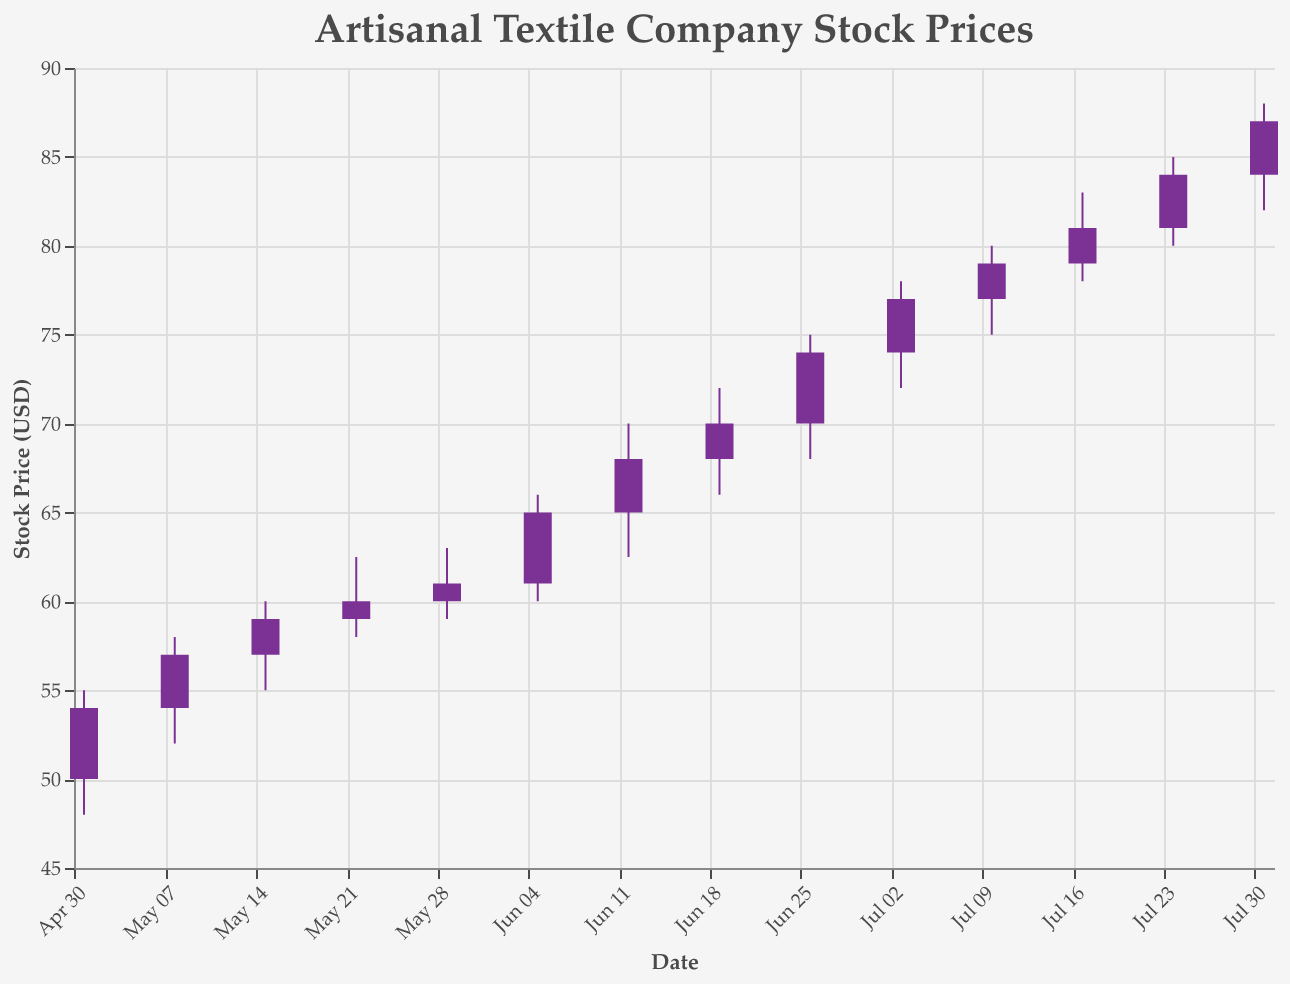How many candlesticks in the plot indicate a rise in stock price? To find the number of candlesticks that indicate a rise in the stock price, look for bars that are colored differently indicating an increase (open price is less than close price). Count these candlesticks from the plot.
Answer: 13 What is the closing price on July 31st, 2023? Locate the candlestick corresponding to July 31st, 2023 on the x-axis. Check the top of the thicker part of the candlestick for the closing price.
Answer: 87.00 Which week experienced the highest trading volume? Check the y-axis values related to the volume of shares traded each week. Identify the candlestick/use the associated line showing the volume. Look for the week with the highest volume.
Answer: July 31st, 2023 What is the difference between the highest and lowest price on June 12th, 2023? Locate the candlestick for June 12th, 2023. Identify the highest (70.00) and lowest (62.50) prices of the day and calculate the difference. 70.00 - 62.50 = 7.50
Answer: 7.50 From May 1st, 2023, to July 31st, 2023, which week had the largest increase in closing price from the previous week? Review the closing prices at the end of each candlestick and determine the differences between successive weeks. Find the week with the largest positive difference. Calculate the increase from each week. The largest increase of 5.00 is from June 26th (74.00) to July 3rd (77.00).
Answer: July 3rd, 2023 What is the average closing price in July 2023? Identify and sum the closing prices of the candlesticks falling in July 2023 (77.00, 79.00, 81.00, 84.00, 87.00). Calculate the average by dividing the sum by 5. (77.00 + 79.00 + 81.00 + 84.00 + 87.00) / 5 = 81.60
Answer: 81.60 How many times did the stock price close above $70 from May 1st to July 31st, 2023? Count the number of candlesticks where the closing price (top of the thick candle part) is above $70.0. Check from June 5th to July 31st. 9 occurrences found.
Answer: 9 